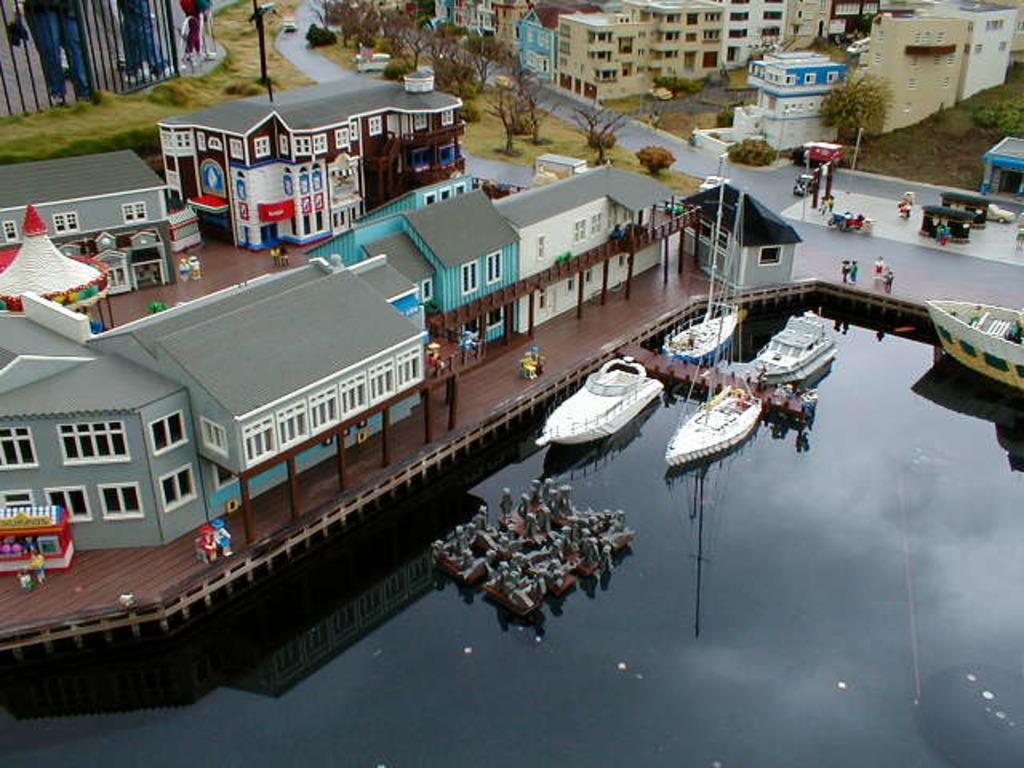Can you describe this image briefly? This is an aerial view and here we can see buildings, trees, poles, vehicles and people on the road and there are boats on the water. 